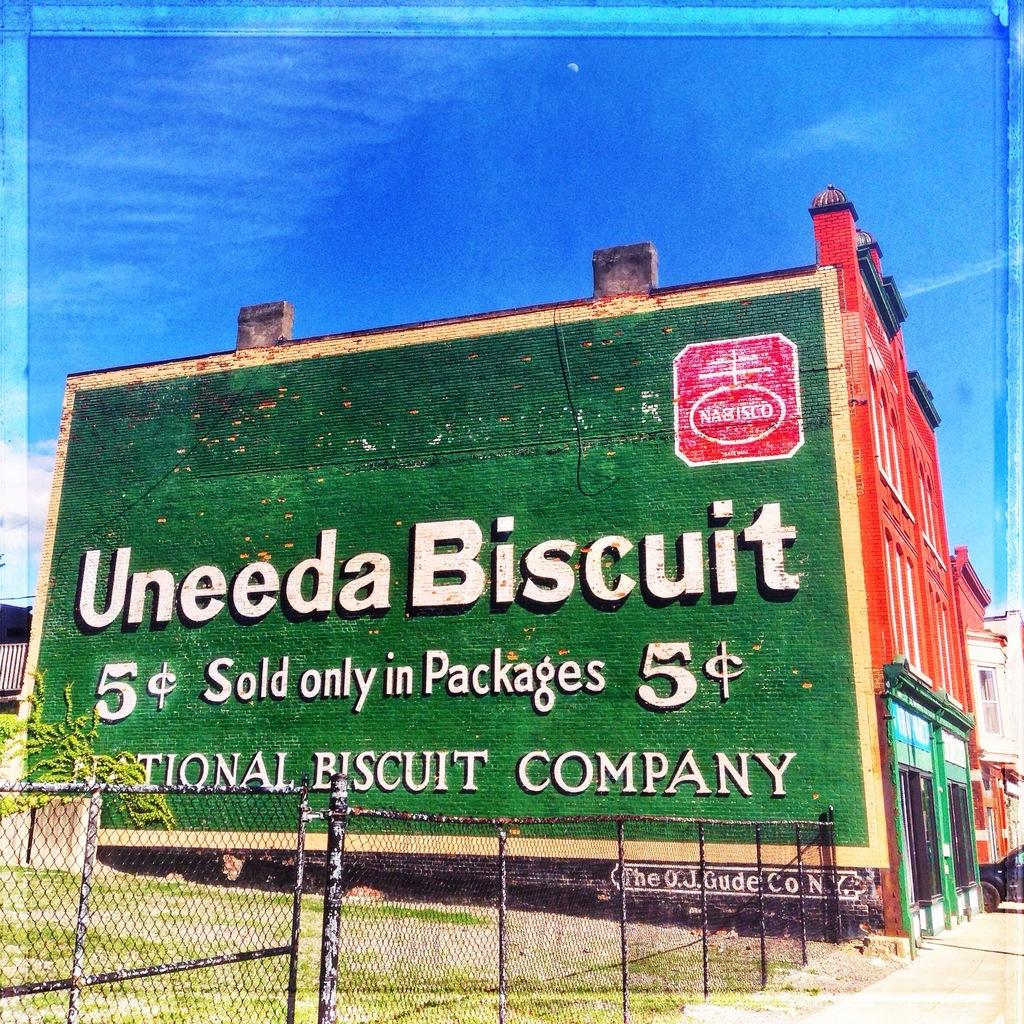<image>
Summarize the visual content of the image. A huge advert adorns the side of a building telling us about nabisco Uneeda Biscuits. 